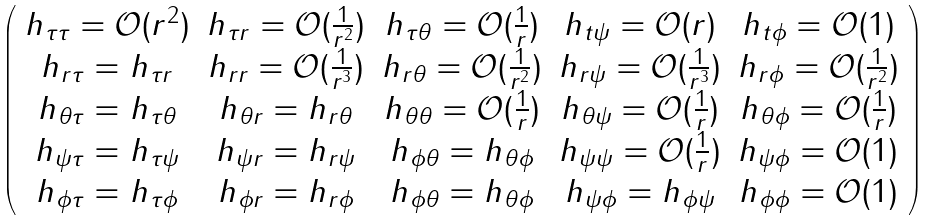Convert formula to latex. <formula><loc_0><loc_0><loc_500><loc_500>\left ( \begin{array} { c c c c c } h _ { \tau \tau } = \mathcal { O } ( r ^ { 2 } ) & h _ { \tau r } = \mathcal { O } ( \frac { 1 } { r ^ { 2 } } ) & h _ { \tau \theta } = \mathcal { O } ( \frac { 1 } { r } ) & h _ { t \psi } = \mathcal { O } ( r ) & h _ { t \phi } = \mathcal { O } ( 1 ) \\ h _ { r \tau } = h _ { \tau r } & h _ { r r } = \mathcal { O } ( \frac { 1 } { r ^ { 3 } } ) & h _ { r \theta } = \mathcal { O } ( \frac { 1 } { r ^ { 2 } } ) & h _ { r \psi } = \mathcal { O } ( \frac { 1 } { r ^ { 3 } } ) & h _ { r \phi } = \mathcal { O } ( \frac { 1 } { r ^ { 2 } } ) \\ h _ { \theta \tau } = h _ { \tau \theta } & h _ { \theta r } = h _ { r \theta } & h _ { \theta \theta } = \mathcal { O } ( \frac { 1 } { r } ) & h _ { \theta \psi } = \mathcal { O } ( \frac { 1 } { r } ) & h _ { \theta \phi } = \mathcal { O } ( \frac { 1 } { r } ) \\ h _ { \psi \tau } = h _ { \tau \psi } & h _ { \psi r } = h _ { r \psi } & h _ { \phi \theta } = h _ { \theta \phi } & h _ { \psi \psi } = \mathcal { O } ( \frac { 1 } { r } ) & h _ { \psi \phi } = \mathcal { O } ( 1 ) \\ h _ { \phi \tau } = h _ { \tau \phi } & h _ { \phi r } = h _ { r \phi } & h _ { \phi \theta } = h _ { \theta \phi } & h _ { \psi \phi } = h _ { \phi \psi } & h _ { \phi \phi } = \mathcal { O } ( 1 ) \end{array} \right )</formula> 